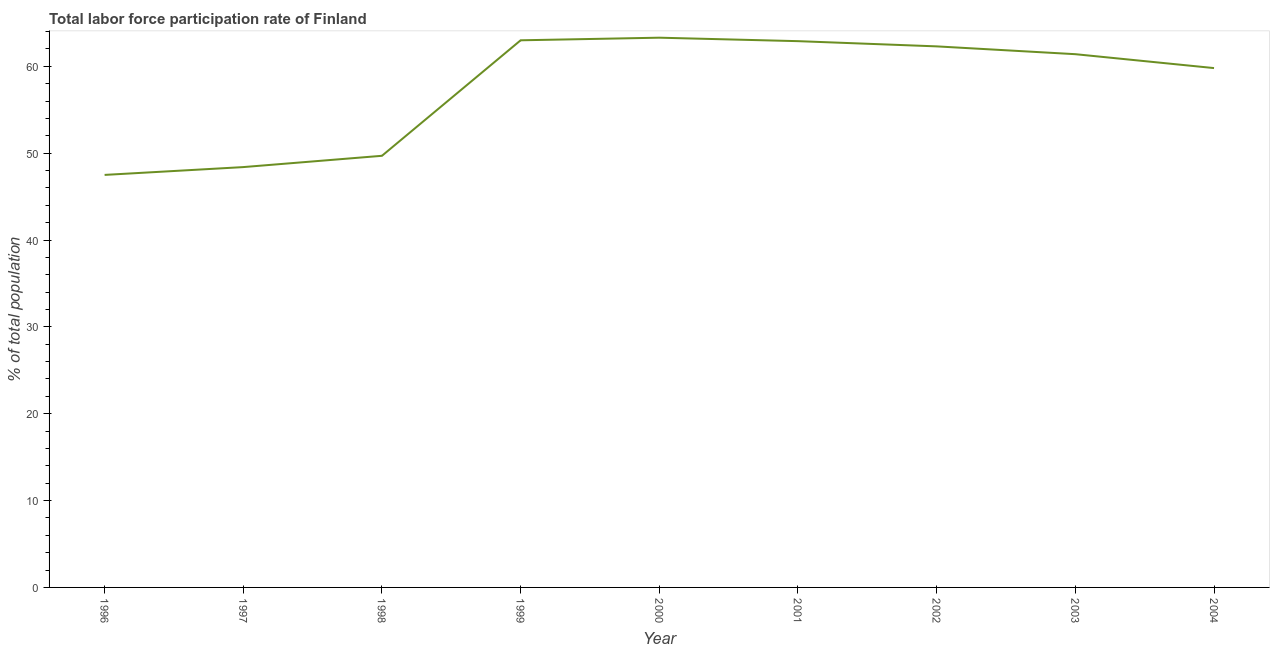What is the total labor force participation rate in 1996?
Offer a terse response. 47.5. Across all years, what is the maximum total labor force participation rate?
Provide a succinct answer. 63.3. Across all years, what is the minimum total labor force participation rate?
Offer a terse response. 47.5. What is the sum of the total labor force participation rate?
Give a very brief answer. 518.3. What is the difference between the total labor force participation rate in 1997 and 1998?
Your answer should be compact. -1.3. What is the average total labor force participation rate per year?
Your response must be concise. 57.59. What is the median total labor force participation rate?
Provide a succinct answer. 61.4. In how many years, is the total labor force participation rate greater than 22 %?
Offer a very short reply. 9. Do a majority of the years between 1996 and 2002 (inclusive) have total labor force participation rate greater than 46 %?
Ensure brevity in your answer.  Yes. What is the ratio of the total labor force participation rate in 1998 to that in 2001?
Ensure brevity in your answer.  0.79. Is the difference between the total labor force participation rate in 1996 and 1999 greater than the difference between any two years?
Your answer should be compact. No. What is the difference between the highest and the second highest total labor force participation rate?
Keep it short and to the point. 0.3. Is the sum of the total labor force participation rate in 1997 and 2002 greater than the maximum total labor force participation rate across all years?
Give a very brief answer. Yes. What is the difference between the highest and the lowest total labor force participation rate?
Give a very brief answer. 15.8. Does the total labor force participation rate monotonically increase over the years?
Your answer should be compact. No. How many lines are there?
Give a very brief answer. 1. How many years are there in the graph?
Provide a short and direct response. 9. What is the difference between two consecutive major ticks on the Y-axis?
Offer a very short reply. 10. Are the values on the major ticks of Y-axis written in scientific E-notation?
Your answer should be very brief. No. Does the graph contain any zero values?
Make the answer very short. No. What is the title of the graph?
Your answer should be compact. Total labor force participation rate of Finland. What is the label or title of the X-axis?
Your response must be concise. Year. What is the label or title of the Y-axis?
Give a very brief answer. % of total population. What is the % of total population in 1996?
Give a very brief answer. 47.5. What is the % of total population of 1997?
Keep it short and to the point. 48.4. What is the % of total population in 1998?
Give a very brief answer. 49.7. What is the % of total population of 2000?
Make the answer very short. 63.3. What is the % of total population of 2001?
Provide a short and direct response. 62.9. What is the % of total population in 2002?
Offer a very short reply. 62.3. What is the % of total population of 2003?
Ensure brevity in your answer.  61.4. What is the % of total population in 2004?
Make the answer very short. 59.8. What is the difference between the % of total population in 1996 and 1999?
Provide a short and direct response. -15.5. What is the difference between the % of total population in 1996 and 2000?
Ensure brevity in your answer.  -15.8. What is the difference between the % of total population in 1996 and 2001?
Ensure brevity in your answer.  -15.4. What is the difference between the % of total population in 1996 and 2002?
Provide a short and direct response. -14.8. What is the difference between the % of total population in 1996 and 2004?
Provide a short and direct response. -12.3. What is the difference between the % of total population in 1997 and 1998?
Your response must be concise. -1.3. What is the difference between the % of total population in 1997 and 1999?
Give a very brief answer. -14.6. What is the difference between the % of total population in 1997 and 2000?
Offer a very short reply. -14.9. What is the difference between the % of total population in 1997 and 2001?
Keep it short and to the point. -14.5. What is the difference between the % of total population in 1998 and 1999?
Ensure brevity in your answer.  -13.3. What is the difference between the % of total population in 1998 and 2000?
Your response must be concise. -13.6. What is the difference between the % of total population in 1998 and 2002?
Ensure brevity in your answer.  -12.6. What is the difference between the % of total population in 1998 and 2004?
Keep it short and to the point. -10.1. What is the difference between the % of total population in 1999 and 2000?
Provide a succinct answer. -0.3. What is the difference between the % of total population in 1999 and 2001?
Provide a short and direct response. 0.1. What is the difference between the % of total population in 1999 and 2004?
Ensure brevity in your answer.  3.2. What is the difference between the % of total population in 2000 and 2004?
Your response must be concise. 3.5. What is the difference between the % of total population in 2001 and 2004?
Give a very brief answer. 3.1. What is the difference between the % of total population in 2002 and 2003?
Give a very brief answer. 0.9. What is the difference between the % of total population in 2002 and 2004?
Offer a very short reply. 2.5. What is the difference between the % of total population in 2003 and 2004?
Your answer should be compact. 1.6. What is the ratio of the % of total population in 1996 to that in 1997?
Ensure brevity in your answer.  0.98. What is the ratio of the % of total population in 1996 to that in 1998?
Provide a succinct answer. 0.96. What is the ratio of the % of total population in 1996 to that in 1999?
Keep it short and to the point. 0.75. What is the ratio of the % of total population in 1996 to that in 2000?
Ensure brevity in your answer.  0.75. What is the ratio of the % of total population in 1996 to that in 2001?
Ensure brevity in your answer.  0.76. What is the ratio of the % of total population in 1996 to that in 2002?
Offer a very short reply. 0.76. What is the ratio of the % of total population in 1996 to that in 2003?
Offer a terse response. 0.77. What is the ratio of the % of total population in 1996 to that in 2004?
Keep it short and to the point. 0.79. What is the ratio of the % of total population in 1997 to that in 1999?
Keep it short and to the point. 0.77. What is the ratio of the % of total population in 1997 to that in 2000?
Ensure brevity in your answer.  0.77. What is the ratio of the % of total population in 1997 to that in 2001?
Your response must be concise. 0.77. What is the ratio of the % of total population in 1997 to that in 2002?
Provide a succinct answer. 0.78. What is the ratio of the % of total population in 1997 to that in 2003?
Give a very brief answer. 0.79. What is the ratio of the % of total population in 1997 to that in 2004?
Your answer should be compact. 0.81. What is the ratio of the % of total population in 1998 to that in 1999?
Provide a short and direct response. 0.79. What is the ratio of the % of total population in 1998 to that in 2000?
Give a very brief answer. 0.79. What is the ratio of the % of total population in 1998 to that in 2001?
Make the answer very short. 0.79. What is the ratio of the % of total population in 1998 to that in 2002?
Give a very brief answer. 0.8. What is the ratio of the % of total population in 1998 to that in 2003?
Keep it short and to the point. 0.81. What is the ratio of the % of total population in 1998 to that in 2004?
Keep it short and to the point. 0.83. What is the ratio of the % of total population in 1999 to that in 2000?
Offer a terse response. 0.99. What is the ratio of the % of total population in 1999 to that in 2002?
Offer a very short reply. 1.01. What is the ratio of the % of total population in 1999 to that in 2003?
Offer a very short reply. 1.03. What is the ratio of the % of total population in 1999 to that in 2004?
Ensure brevity in your answer.  1.05. What is the ratio of the % of total population in 2000 to that in 2003?
Your answer should be compact. 1.03. What is the ratio of the % of total population in 2000 to that in 2004?
Your answer should be very brief. 1.06. What is the ratio of the % of total population in 2001 to that in 2002?
Make the answer very short. 1.01. What is the ratio of the % of total population in 2001 to that in 2004?
Offer a very short reply. 1.05. What is the ratio of the % of total population in 2002 to that in 2003?
Your answer should be very brief. 1.01. What is the ratio of the % of total population in 2002 to that in 2004?
Provide a succinct answer. 1.04. 